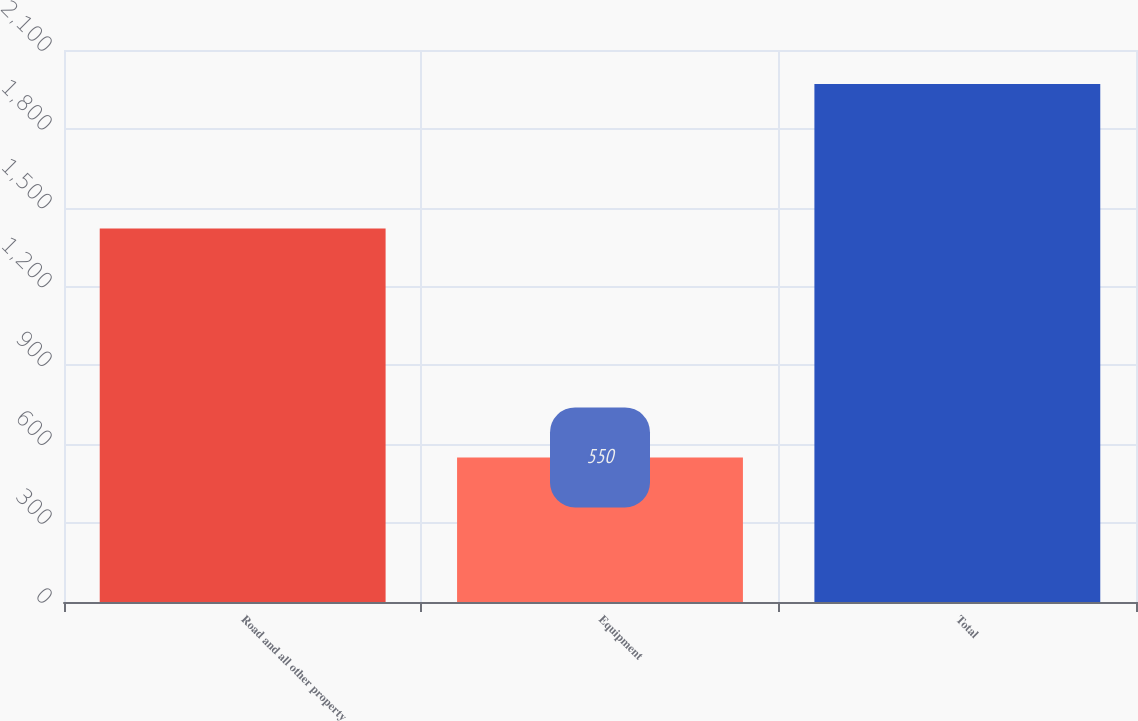Convert chart. <chart><loc_0><loc_0><loc_500><loc_500><bar_chart><fcel>Road and all other property<fcel>Equipment<fcel>Total<nl><fcel>1421<fcel>550<fcel>1971<nl></chart> 